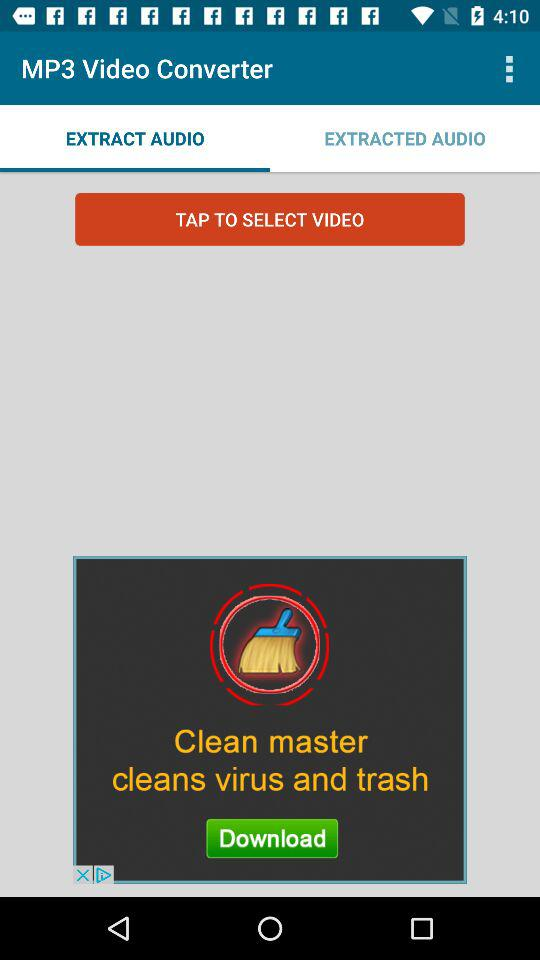What is the application name? The application name is "MP3 Video Converter". 